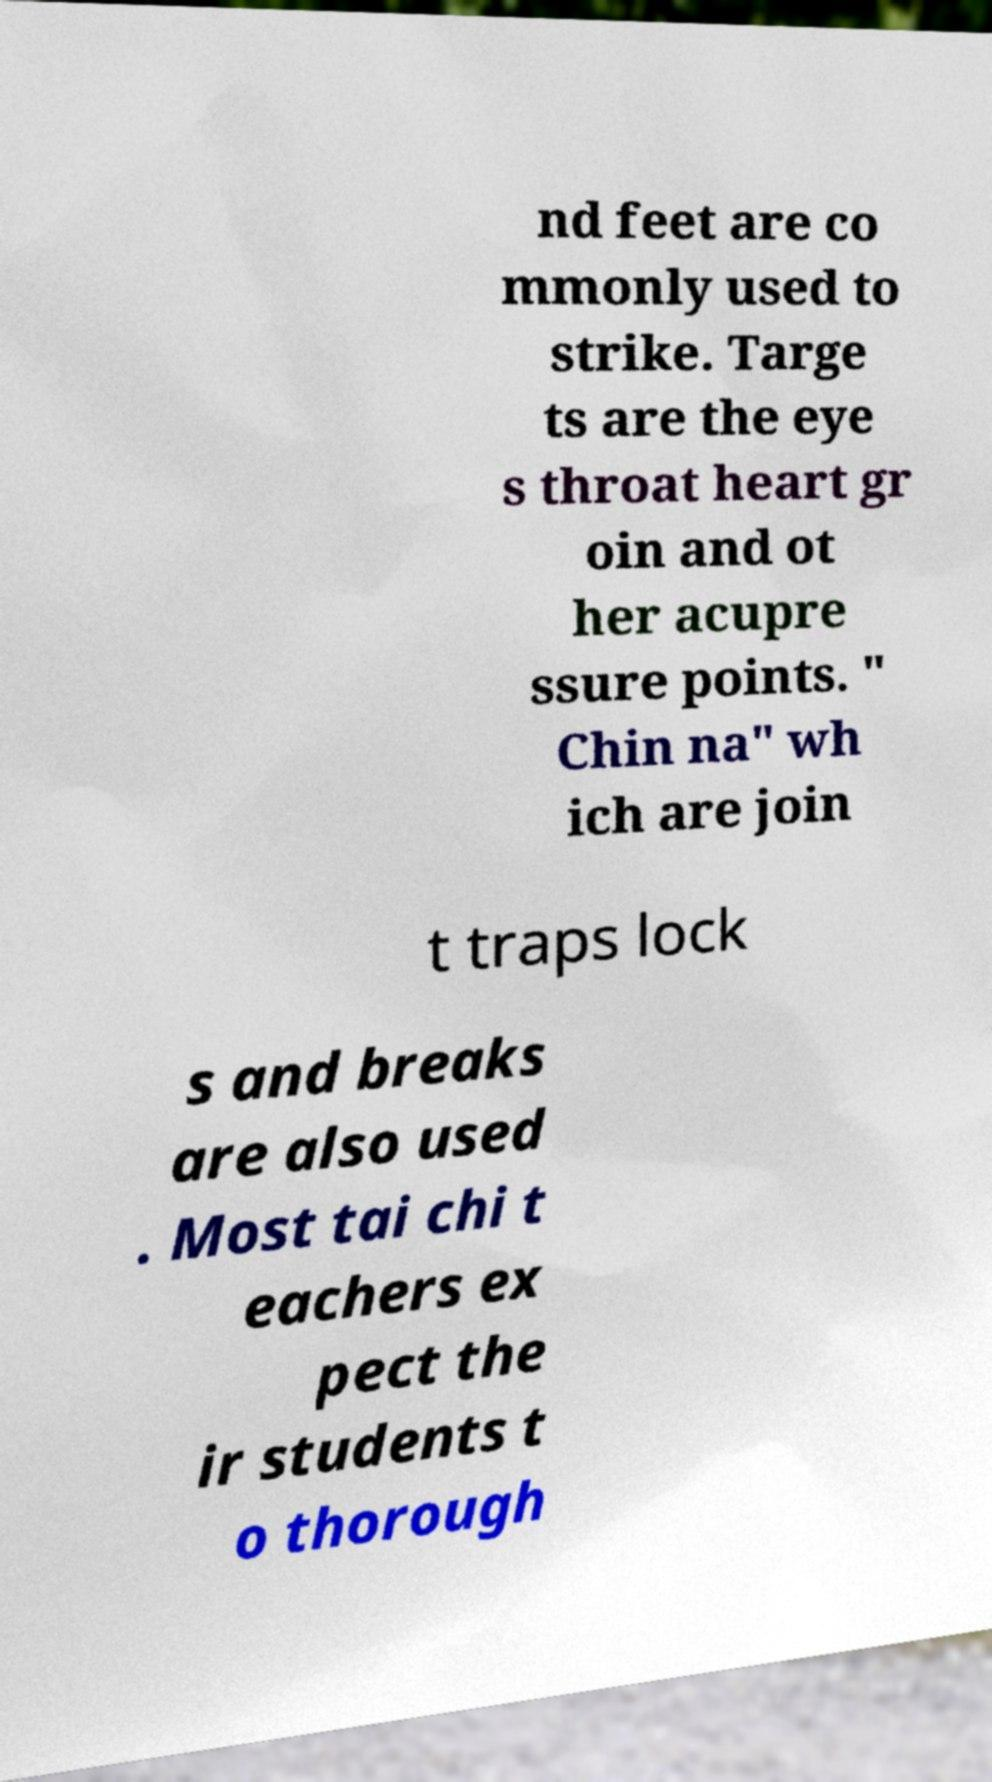Please identify and transcribe the text found in this image. nd feet are co mmonly used to strike. Targe ts are the eye s throat heart gr oin and ot her acupre ssure points. " Chin na" wh ich are join t traps lock s and breaks are also used . Most tai chi t eachers ex pect the ir students t o thorough 